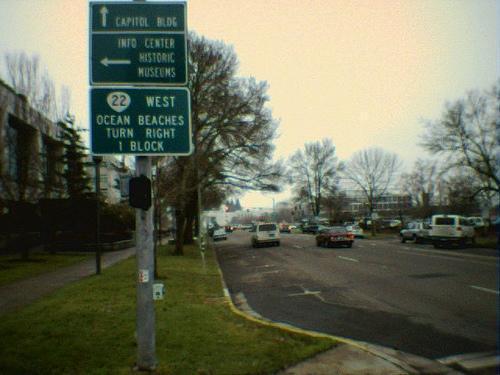How many signs are on the post?
Give a very brief answer. 3. 